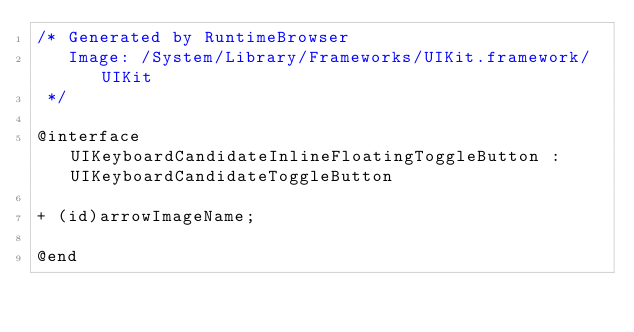Convert code to text. <code><loc_0><loc_0><loc_500><loc_500><_C_>/* Generated by RuntimeBrowser
   Image: /System/Library/Frameworks/UIKit.framework/UIKit
 */

@interface UIKeyboardCandidateInlineFloatingToggleButton : UIKeyboardCandidateToggleButton

+ (id)arrowImageName;

@end
</code> 